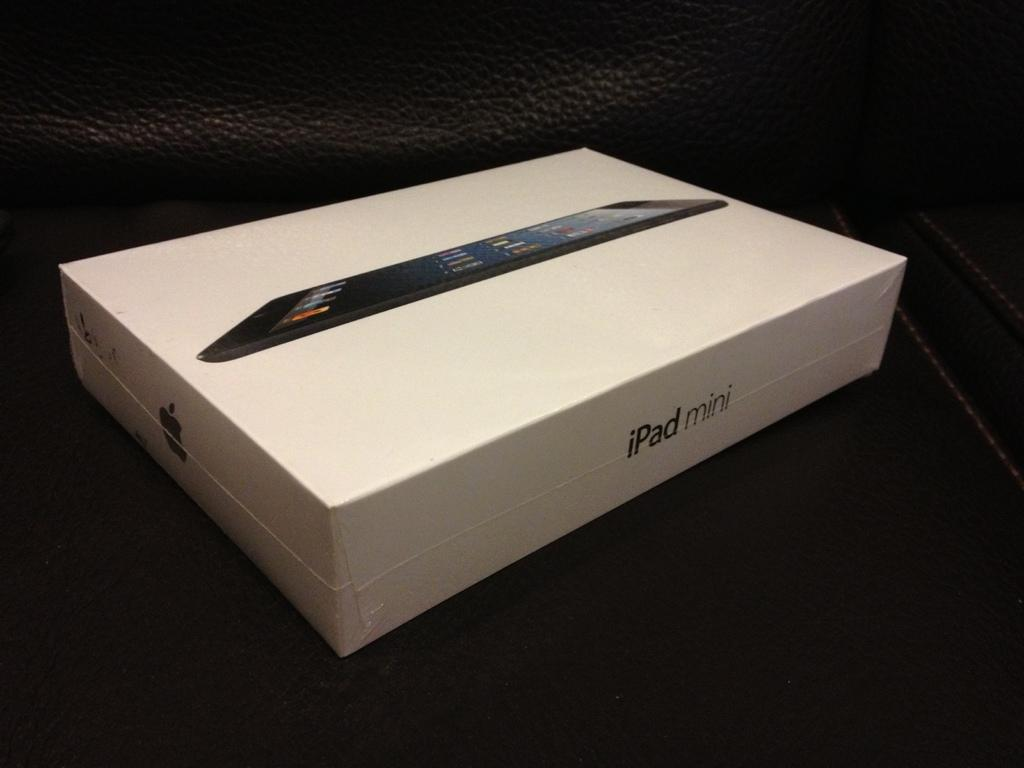<image>
Summarize the visual content of the image. A white box containing an apple ipad mini 